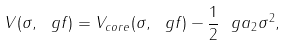Convert formula to latex. <formula><loc_0><loc_0><loc_500><loc_500>V ( \sigma , \ g f ) = V _ { c o r e } ( \sigma , \ g f ) - \frac { 1 } { 2 } \ g a _ { 2 } \sigma ^ { 2 } ,</formula> 